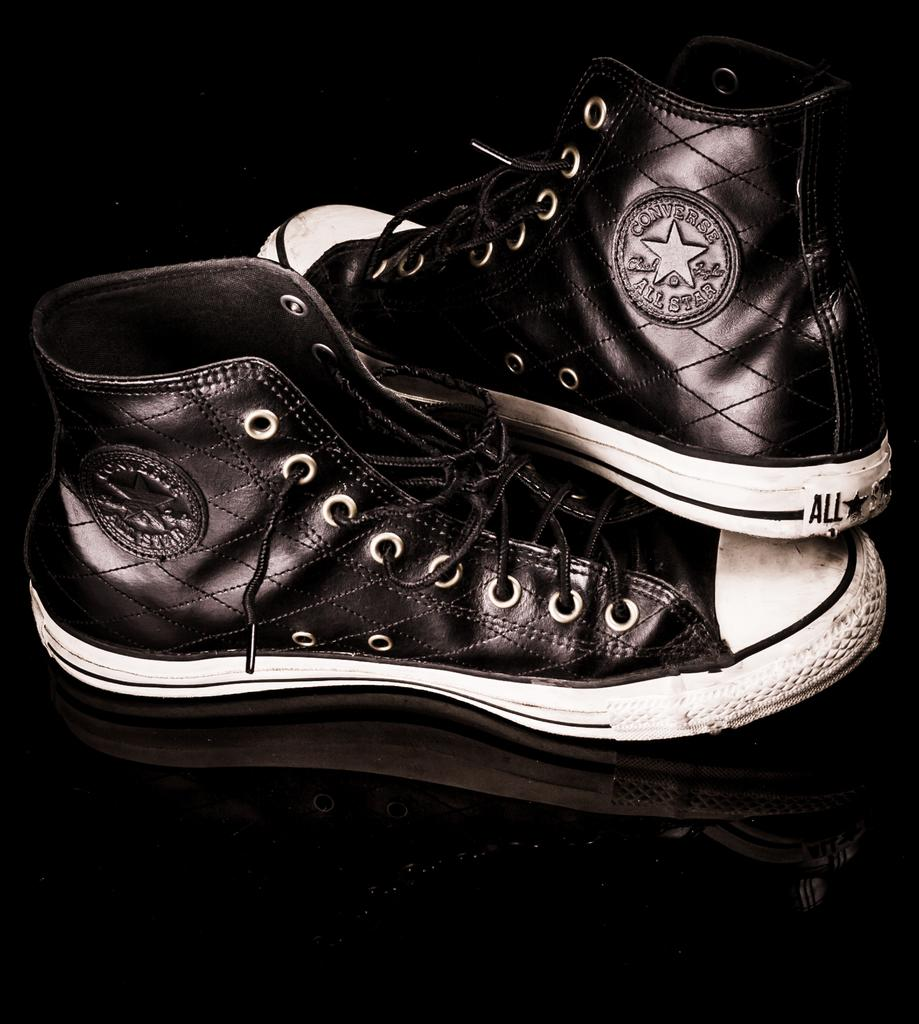What type of footwear is visible in the image? There is a pair of shoes in the image. What colors are the shoes? The shoes are black and white in color. How many horses are present in the image? There are no horses present in the image; it only features a pair of shoes. What type of system is being used to organize the shoes in the image? There is no system visible in the image for organizing the shoes; they are simply placed on a surface. 